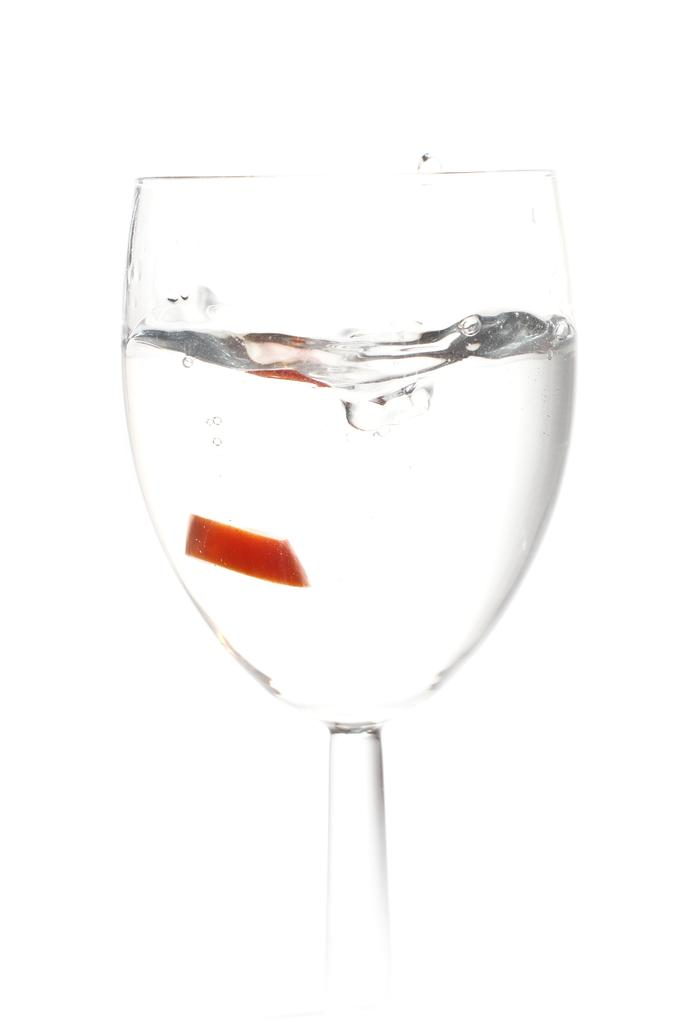What is the main subject of the image? The image contains a piece of art. Can you describe any specific elements within the art? There is a glass with some liquid in the art. What color is the background of the art? The background of the art is white. How many toes can be seen on the fang in the image? There is no fang or toe present in the image; it contains a piece of art with a glass and a white background. 